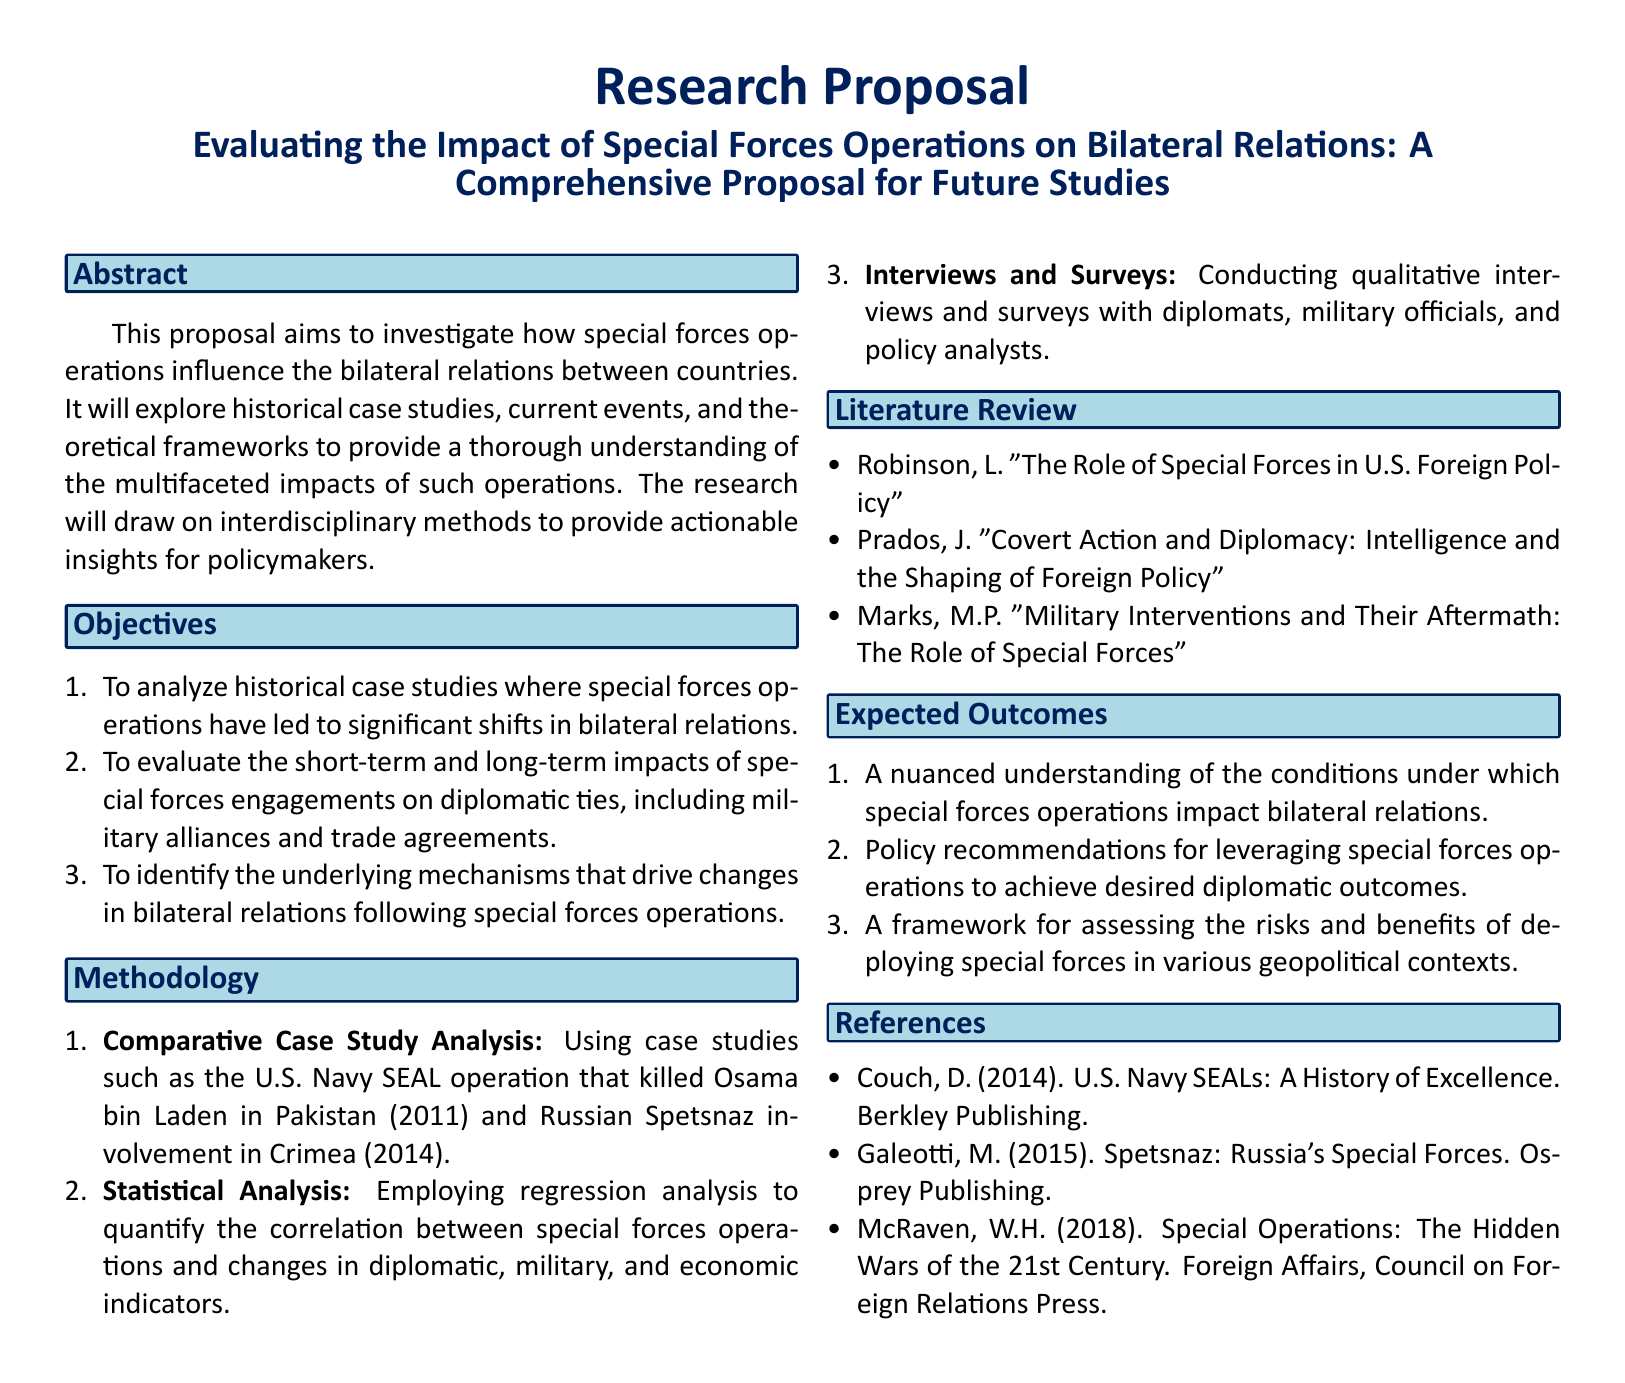What is the title of the proposal? The title outlines the specific focus of the research on special forces and bilateral relations.
Answer: Evaluating the Impact of Special Forces Operations on Bilateral Relations: A Comprehensive Proposal for Future Studies What year was the U.S. Navy SEAL operation that killed Osama bin Laden? The proposal mentions significant case studies, including one dated 2011.
Answer: 2011 What is the first objective of the research? The first objective highlights the analysis of historical cases to find impacts on bilateral relations.
Answer: To analyze historical case studies where special forces operations have led to significant shifts in bilateral relations Which statistical method will be employed for analysis? The proposal indicates the use of this specific quantitative method for evaluating correlations.
Answer: Regression analysis Who authored the work titled "The Role of Special Forces in U.S. Foreign Policy"? This information can be found in the literature review section regarding relevant research.
Answer: Robinson, L What type of research will involve qualitative interviews and surveys? The methodology section explains the various approaches, specifically this one for gathering qualitative data.
Answer: Interviews and Surveys What is one expected outcome of the research? This outlines what the researchers hope to achieve and convey through their studies.
Answer: A nuanced understanding of the conditions under which special forces operations impact bilateral relations How many main objectives are listed in the proposal? The number of objectives provides insight into the scope of the research.
Answer: Three 